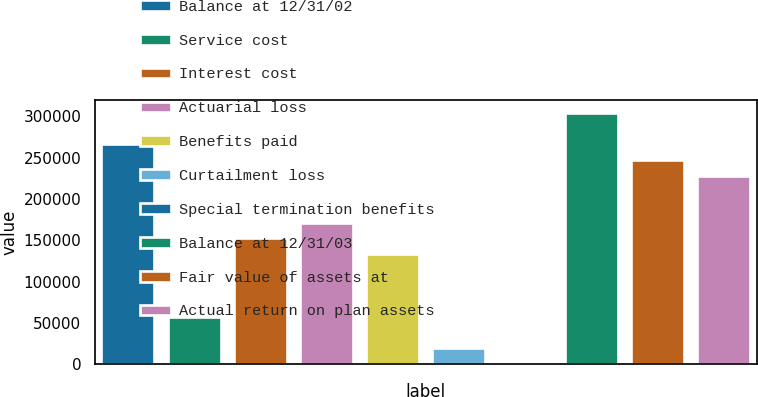Convert chart. <chart><loc_0><loc_0><loc_500><loc_500><bar_chart><fcel>Balance at 12/31/02<fcel>Service cost<fcel>Interest cost<fcel>Actuarial loss<fcel>Benefits paid<fcel>Curtailment loss<fcel>Special termination benefits<fcel>Balance at 12/31/03<fcel>Fair value of assets at<fcel>Actual return on plan assets<nl><fcel>265933<fcel>57622.9<fcel>152309<fcel>171247<fcel>133372<fcel>19748.3<fcel>811<fcel>303808<fcel>246996<fcel>228059<nl></chart> 